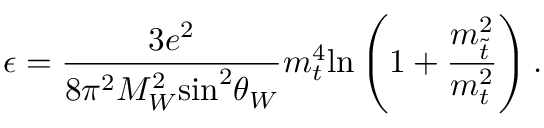<formula> <loc_0><loc_0><loc_500><loc_500>\epsilon = \frac { 3 e ^ { 2 } } { 8 \pi ^ { 2 } M _ { W } ^ { 2 } \sin ^ { 2 } \theta _ { W } } m _ { t } ^ { 4 } \ln \left ( 1 + \frac { { m } _ { \tilde { t } } ^ { 2 } } { m _ { t } ^ { 2 } } \right ) .</formula> 